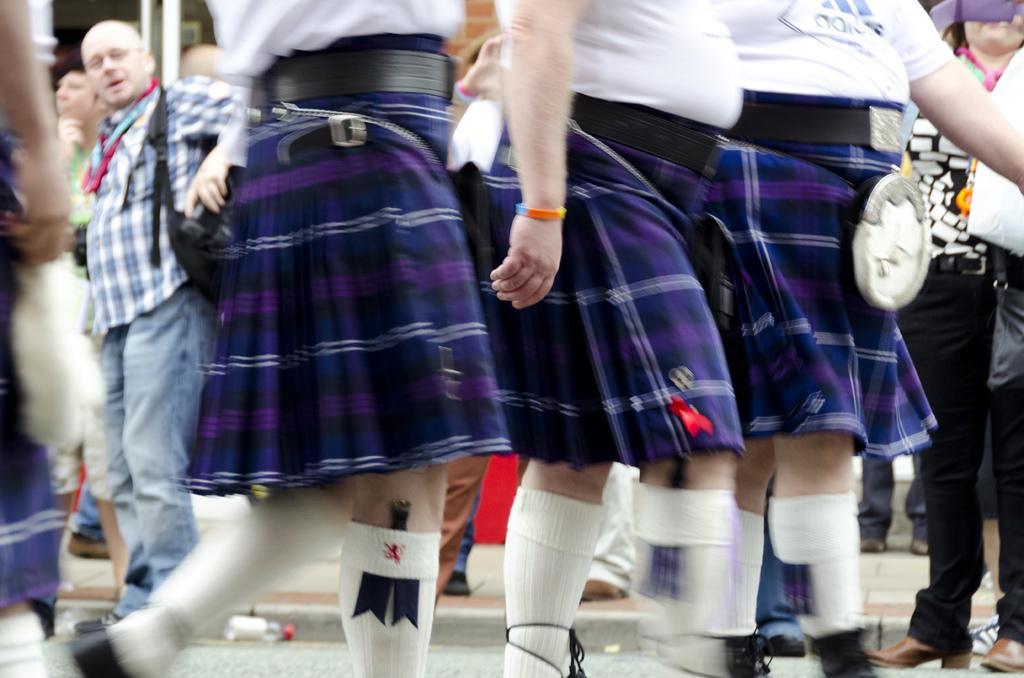Please provide a concise description of this image. In this image we can see three persons wearing white t shirts and blue color skirts and walking on the road. In the background we can also see the people. 